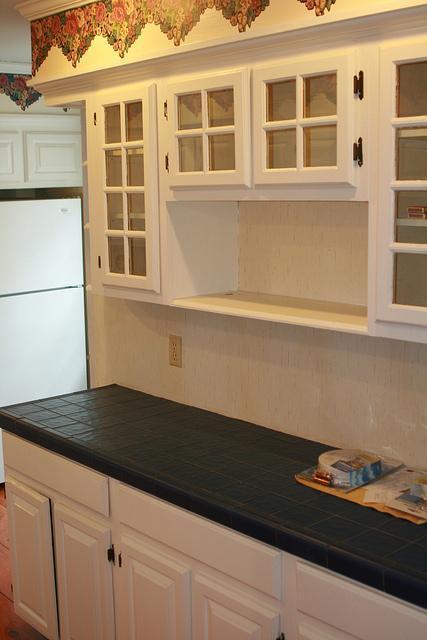How many train cars are orange?
Give a very brief answer. 0. 